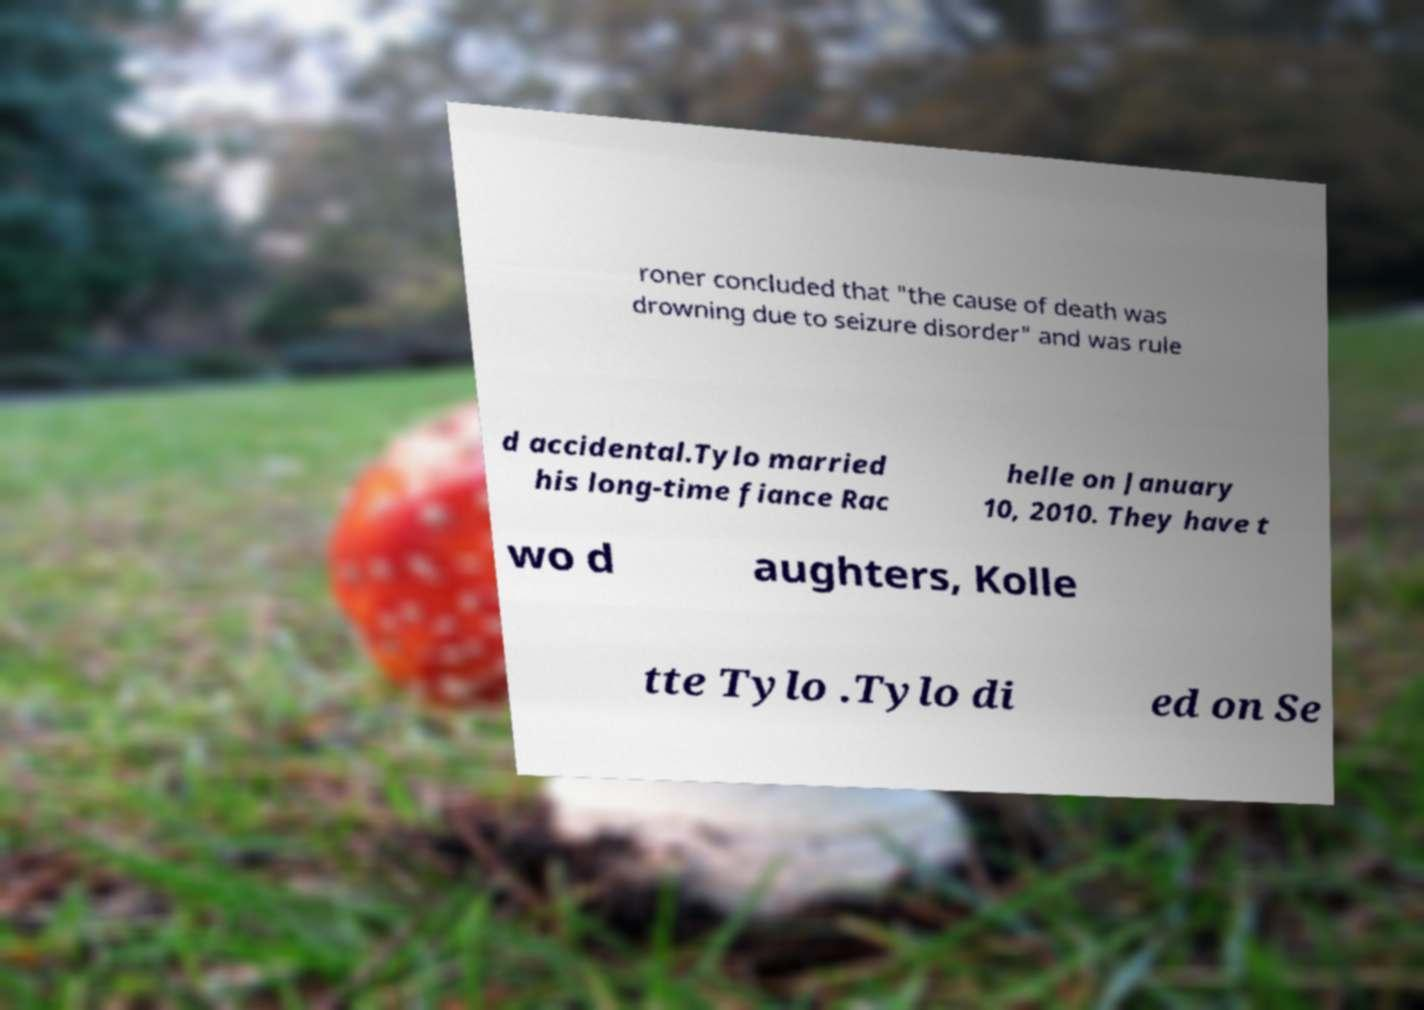Please identify and transcribe the text found in this image. roner concluded that "the cause of death was drowning due to seizure disorder" and was rule d accidental.Tylo married his long-time fiance Rac helle on January 10, 2010. They have t wo d aughters, Kolle tte Tylo .Tylo di ed on Se 